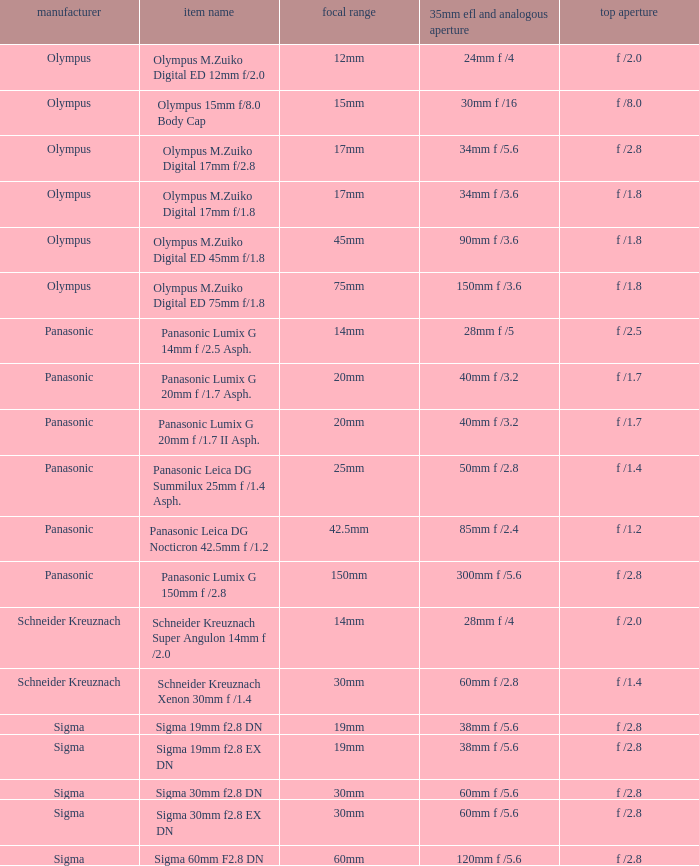What is the 35mm EFL and the equivalent aperture of the lens(es) with a maximum aperture of f /2.5? 28mm f /5. 